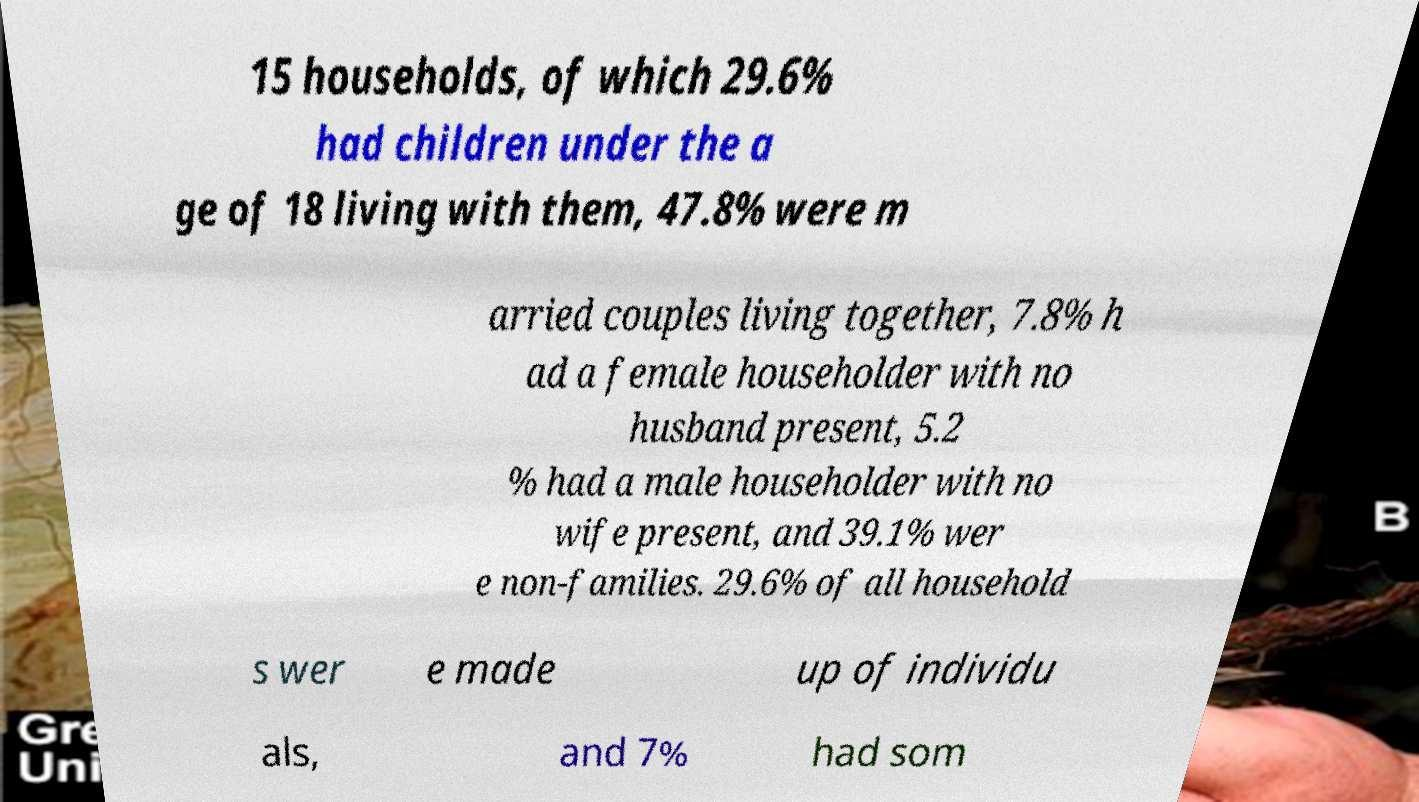Please identify and transcribe the text found in this image. 15 households, of which 29.6% had children under the a ge of 18 living with them, 47.8% were m arried couples living together, 7.8% h ad a female householder with no husband present, 5.2 % had a male householder with no wife present, and 39.1% wer e non-families. 29.6% of all household s wer e made up of individu als, and 7% had som 